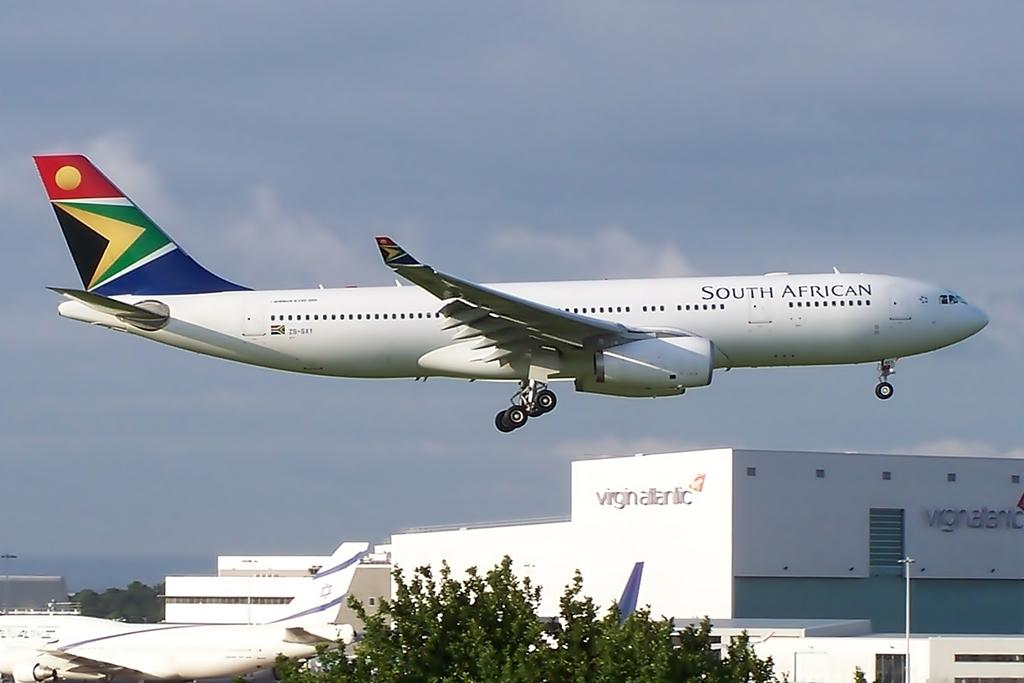Provide a one-sentence caption for the provided image. A South African airways jet flies at a low altitude over airport buildings. 